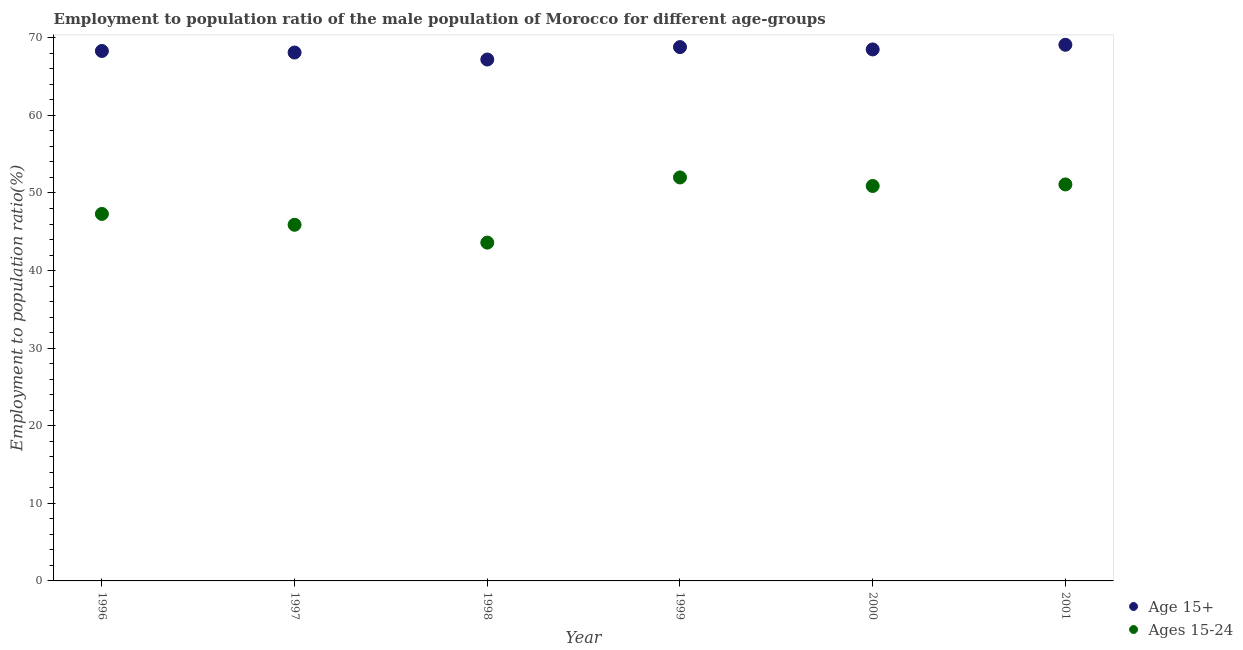What is the employment to population ratio(age 15-24) in 1998?
Provide a short and direct response. 43.6. Across all years, what is the maximum employment to population ratio(age 15+)?
Your response must be concise. 69.1. Across all years, what is the minimum employment to population ratio(age 15-24)?
Your response must be concise. 43.6. What is the total employment to population ratio(age 15+) in the graph?
Provide a succinct answer. 410. What is the difference between the employment to population ratio(age 15-24) in 2000 and that in 2001?
Your answer should be compact. -0.2. What is the difference between the employment to population ratio(age 15+) in 1999 and the employment to population ratio(age 15-24) in 1998?
Offer a terse response. 25.2. What is the average employment to population ratio(age 15+) per year?
Offer a very short reply. 68.33. In the year 1999, what is the difference between the employment to population ratio(age 15+) and employment to population ratio(age 15-24)?
Offer a very short reply. 16.8. What is the ratio of the employment to population ratio(age 15+) in 1997 to that in 1998?
Provide a succinct answer. 1.01. What is the difference between the highest and the second highest employment to population ratio(age 15-24)?
Your answer should be compact. 0.9. What is the difference between the highest and the lowest employment to population ratio(age 15+)?
Offer a terse response. 1.9. Is the employment to population ratio(age 15-24) strictly greater than the employment to population ratio(age 15+) over the years?
Offer a terse response. No. How many dotlines are there?
Provide a succinct answer. 2. How many years are there in the graph?
Keep it short and to the point. 6. What is the difference between two consecutive major ticks on the Y-axis?
Ensure brevity in your answer.  10. Are the values on the major ticks of Y-axis written in scientific E-notation?
Your answer should be very brief. No. Does the graph contain any zero values?
Provide a short and direct response. No. Where does the legend appear in the graph?
Offer a terse response. Bottom right. How many legend labels are there?
Offer a very short reply. 2. How are the legend labels stacked?
Offer a terse response. Vertical. What is the title of the graph?
Keep it short and to the point. Employment to population ratio of the male population of Morocco for different age-groups. What is the label or title of the Y-axis?
Keep it short and to the point. Employment to population ratio(%). What is the Employment to population ratio(%) in Age 15+ in 1996?
Your answer should be very brief. 68.3. What is the Employment to population ratio(%) in Ages 15-24 in 1996?
Give a very brief answer. 47.3. What is the Employment to population ratio(%) of Age 15+ in 1997?
Provide a short and direct response. 68.1. What is the Employment to population ratio(%) in Ages 15-24 in 1997?
Offer a terse response. 45.9. What is the Employment to population ratio(%) in Age 15+ in 1998?
Offer a terse response. 67.2. What is the Employment to population ratio(%) of Ages 15-24 in 1998?
Make the answer very short. 43.6. What is the Employment to population ratio(%) of Age 15+ in 1999?
Make the answer very short. 68.8. What is the Employment to population ratio(%) in Ages 15-24 in 1999?
Ensure brevity in your answer.  52. What is the Employment to population ratio(%) in Age 15+ in 2000?
Your answer should be compact. 68.5. What is the Employment to population ratio(%) in Ages 15-24 in 2000?
Your answer should be very brief. 50.9. What is the Employment to population ratio(%) of Age 15+ in 2001?
Provide a succinct answer. 69.1. What is the Employment to population ratio(%) of Ages 15-24 in 2001?
Offer a very short reply. 51.1. Across all years, what is the maximum Employment to population ratio(%) of Age 15+?
Keep it short and to the point. 69.1. Across all years, what is the minimum Employment to population ratio(%) in Age 15+?
Offer a very short reply. 67.2. Across all years, what is the minimum Employment to population ratio(%) of Ages 15-24?
Your answer should be compact. 43.6. What is the total Employment to population ratio(%) of Age 15+ in the graph?
Give a very brief answer. 410. What is the total Employment to population ratio(%) in Ages 15-24 in the graph?
Provide a short and direct response. 290.8. What is the difference between the Employment to population ratio(%) of Ages 15-24 in 1996 and that in 1998?
Offer a very short reply. 3.7. What is the difference between the Employment to population ratio(%) in Age 15+ in 1996 and that in 1999?
Your answer should be very brief. -0.5. What is the difference between the Employment to population ratio(%) in Ages 15-24 in 1996 and that in 1999?
Your answer should be compact. -4.7. What is the difference between the Employment to population ratio(%) of Age 15+ in 1996 and that in 2000?
Provide a short and direct response. -0.2. What is the difference between the Employment to population ratio(%) in Ages 15-24 in 1996 and that in 2000?
Provide a short and direct response. -3.6. What is the difference between the Employment to population ratio(%) of Age 15+ in 1997 and that in 1998?
Give a very brief answer. 0.9. What is the difference between the Employment to population ratio(%) in Ages 15-24 in 1997 and that in 1998?
Your answer should be compact. 2.3. What is the difference between the Employment to population ratio(%) of Ages 15-24 in 1997 and that in 1999?
Offer a terse response. -6.1. What is the difference between the Employment to population ratio(%) in Age 15+ in 1997 and that in 2000?
Provide a short and direct response. -0.4. What is the difference between the Employment to population ratio(%) of Age 15+ in 1998 and that in 1999?
Offer a very short reply. -1.6. What is the difference between the Employment to population ratio(%) in Ages 15-24 in 1998 and that in 2001?
Provide a succinct answer. -7.5. What is the difference between the Employment to population ratio(%) of Age 15+ in 1999 and that in 2000?
Offer a terse response. 0.3. What is the difference between the Employment to population ratio(%) of Ages 15-24 in 1999 and that in 2000?
Your response must be concise. 1.1. What is the difference between the Employment to population ratio(%) of Ages 15-24 in 1999 and that in 2001?
Offer a very short reply. 0.9. What is the difference between the Employment to population ratio(%) in Ages 15-24 in 2000 and that in 2001?
Provide a short and direct response. -0.2. What is the difference between the Employment to population ratio(%) of Age 15+ in 1996 and the Employment to population ratio(%) of Ages 15-24 in 1997?
Keep it short and to the point. 22.4. What is the difference between the Employment to population ratio(%) in Age 15+ in 1996 and the Employment to population ratio(%) in Ages 15-24 in 1998?
Keep it short and to the point. 24.7. What is the difference between the Employment to population ratio(%) in Age 15+ in 1996 and the Employment to population ratio(%) in Ages 15-24 in 2000?
Your answer should be very brief. 17.4. What is the difference between the Employment to population ratio(%) in Age 15+ in 1996 and the Employment to population ratio(%) in Ages 15-24 in 2001?
Offer a very short reply. 17.2. What is the difference between the Employment to population ratio(%) in Age 15+ in 1997 and the Employment to population ratio(%) in Ages 15-24 in 1998?
Provide a succinct answer. 24.5. What is the difference between the Employment to population ratio(%) in Age 15+ in 1997 and the Employment to population ratio(%) in Ages 15-24 in 1999?
Keep it short and to the point. 16.1. What is the difference between the Employment to population ratio(%) of Age 15+ in 1997 and the Employment to population ratio(%) of Ages 15-24 in 2000?
Provide a succinct answer. 17.2. What is the difference between the Employment to population ratio(%) of Age 15+ in 1999 and the Employment to population ratio(%) of Ages 15-24 in 2000?
Provide a succinct answer. 17.9. What is the difference between the Employment to population ratio(%) of Age 15+ in 2000 and the Employment to population ratio(%) of Ages 15-24 in 2001?
Offer a very short reply. 17.4. What is the average Employment to population ratio(%) in Age 15+ per year?
Your answer should be very brief. 68.33. What is the average Employment to population ratio(%) in Ages 15-24 per year?
Provide a succinct answer. 48.47. In the year 1998, what is the difference between the Employment to population ratio(%) of Age 15+ and Employment to population ratio(%) of Ages 15-24?
Give a very brief answer. 23.6. In the year 2000, what is the difference between the Employment to population ratio(%) in Age 15+ and Employment to population ratio(%) in Ages 15-24?
Make the answer very short. 17.6. What is the ratio of the Employment to population ratio(%) in Age 15+ in 1996 to that in 1997?
Provide a short and direct response. 1. What is the ratio of the Employment to population ratio(%) in Ages 15-24 in 1996 to that in 1997?
Give a very brief answer. 1.03. What is the ratio of the Employment to population ratio(%) in Age 15+ in 1996 to that in 1998?
Provide a short and direct response. 1.02. What is the ratio of the Employment to population ratio(%) of Ages 15-24 in 1996 to that in 1998?
Keep it short and to the point. 1.08. What is the ratio of the Employment to population ratio(%) of Ages 15-24 in 1996 to that in 1999?
Your answer should be compact. 0.91. What is the ratio of the Employment to population ratio(%) in Ages 15-24 in 1996 to that in 2000?
Make the answer very short. 0.93. What is the ratio of the Employment to population ratio(%) of Age 15+ in 1996 to that in 2001?
Ensure brevity in your answer.  0.99. What is the ratio of the Employment to population ratio(%) in Ages 15-24 in 1996 to that in 2001?
Provide a short and direct response. 0.93. What is the ratio of the Employment to population ratio(%) in Age 15+ in 1997 to that in 1998?
Make the answer very short. 1.01. What is the ratio of the Employment to population ratio(%) in Ages 15-24 in 1997 to that in 1998?
Your response must be concise. 1.05. What is the ratio of the Employment to population ratio(%) of Ages 15-24 in 1997 to that in 1999?
Offer a terse response. 0.88. What is the ratio of the Employment to population ratio(%) in Age 15+ in 1997 to that in 2000?
Ensure brevity in your answer.  0.99. What is the ratio of the Employment to population ratio(%) in Ages 15-24 in 1997 to that in 2000?
Your answer should be compact. 0.9. What is the ratio of the Employment to population ratio(%) of Age 15+ in 1997 to that in 2001?
Give a very brief answer. 0.99. What is the ratio of the Employment to population ratio(%) in Ages 15-24 in 1997 to that in 2001?
Provide a short and direct response. 0.9. What is the ratio of the Employment to population ratio(%) in Age 15+ in 1998 to that in 1999?
Provide a succinct answer. 0.98. What is the ratio of the Employment to population ratio(%) of Ages 15-24 in 1998 to that in 1999?
Ensure brevity in your answer.  0.84. What is the ratio of the Employment to population ratio(%) of Age 15+ in 1998 to that in 2000?
Provide a short and direct response. 0.98. What is the ratio of the Employment to population ratio(%) in Ages 15-24 in 1998 to that in 2000?
Offer a very short reply. 0.86. What is the ratio of the Employment to population ratio(%) of Age 15+ in 1998 to that in 2001?
Your response must be concise. 0.97. What is the ratio of the Employment to population ratio(%) of Ages 15-24 in 1998 to that in 2001?
Offer a very short reply. 0.85. What is the ratio of the Employment to population ratio(%) of Age 15+ in 1999 to that in 2000?
Provide a short and direct response. 1. What is the ratio of the Employment to population ratio(%) in Ages 15-24 in 1999 to that in 2000?
Your answer should be very brief. 1.02. What is the ratio of the Employment to population ratio(%) in Age 15+ in 1999 to that in 2001?
Make the answer very short. 1. What is the ratio of the Employment to population ratio(%) in Ages 15-24 in 1999 to that in 2001?
Your response must be concise. 1.02. What is the difference between the highest and the second highest Employment to population ratio(%) in Ages 15-24?
Offer a terse response. 0.9. 